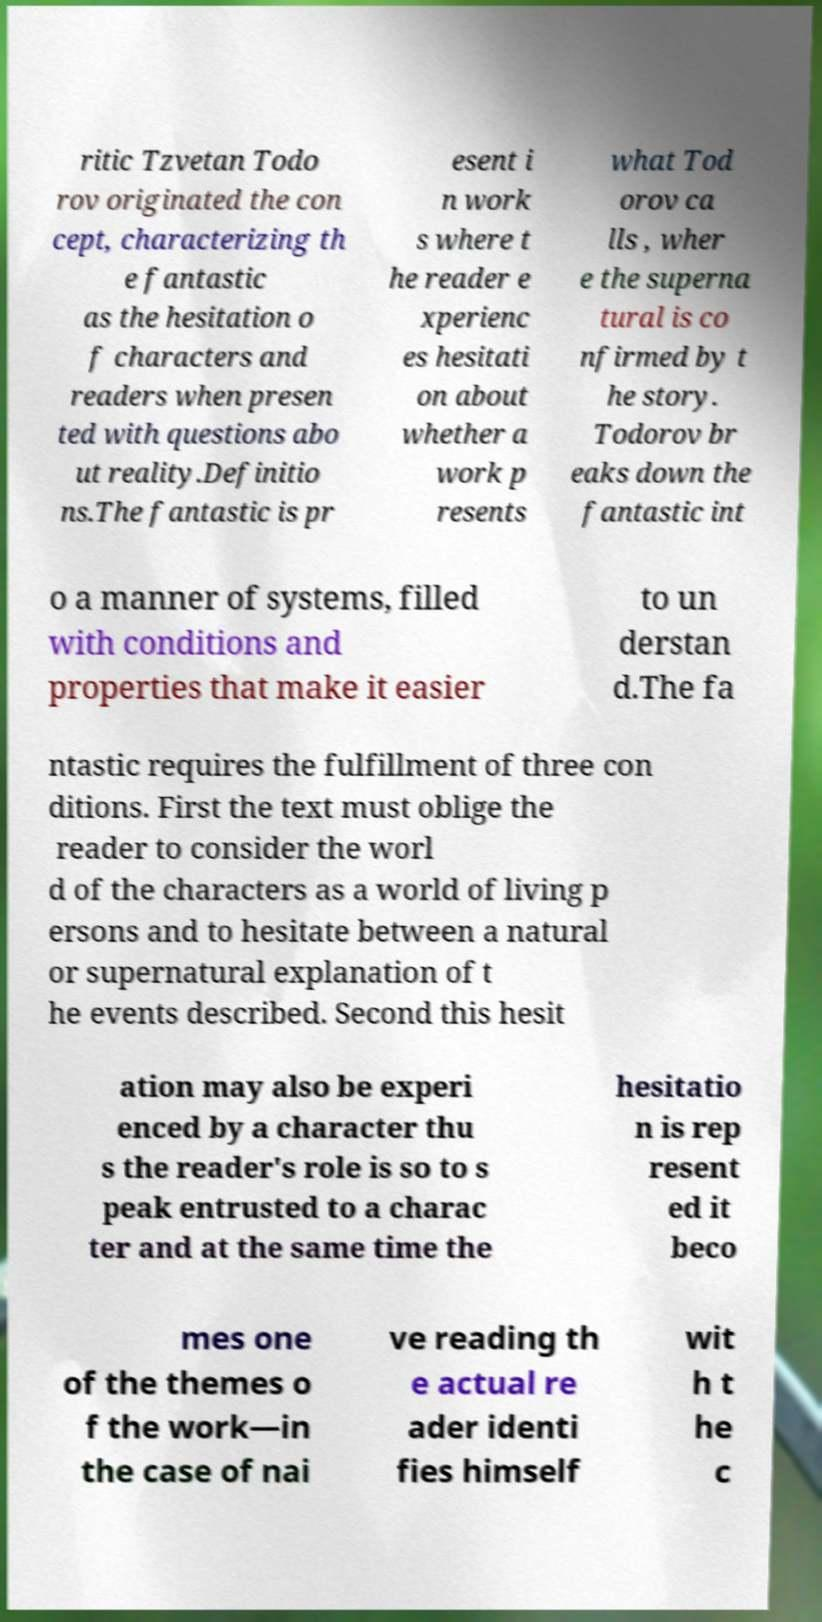Please read and relay the text visible in this image. What does it say? ritic Tzvetan Todo rov originated the con cept, characterizing th e fantastic as the hesitation o f characters and readers when presen ted with questions abo ut reality.Definitio ns.The fantastic is pr esent i n work s where t he reader e xperienc es hesitati on about whether a work p resents what Tod orov ca lls , wher e the superna tural is co nfirmed by t he story. Todorov br eaks down the fantastic int o a manner of systems, filled with conditions and properties that make it easier to un derstan d.The fa ntastic requires the fulfillment of three con ditions. First the text must oblige the reader to consider the worl d of the characters as a world of living p ersons and to hesitate between a natural or supernatural explanation of t he events described. Second this hesit ation may also be experi enced by a character thu s the reader's role is so to s peak entrusted to a charac ter and at the same time the hesitatio n is rep resent ed it beco mes one of the themes o f the work—in the case of nai ve reading th e actual re ader identi fies himself wit h t he c 